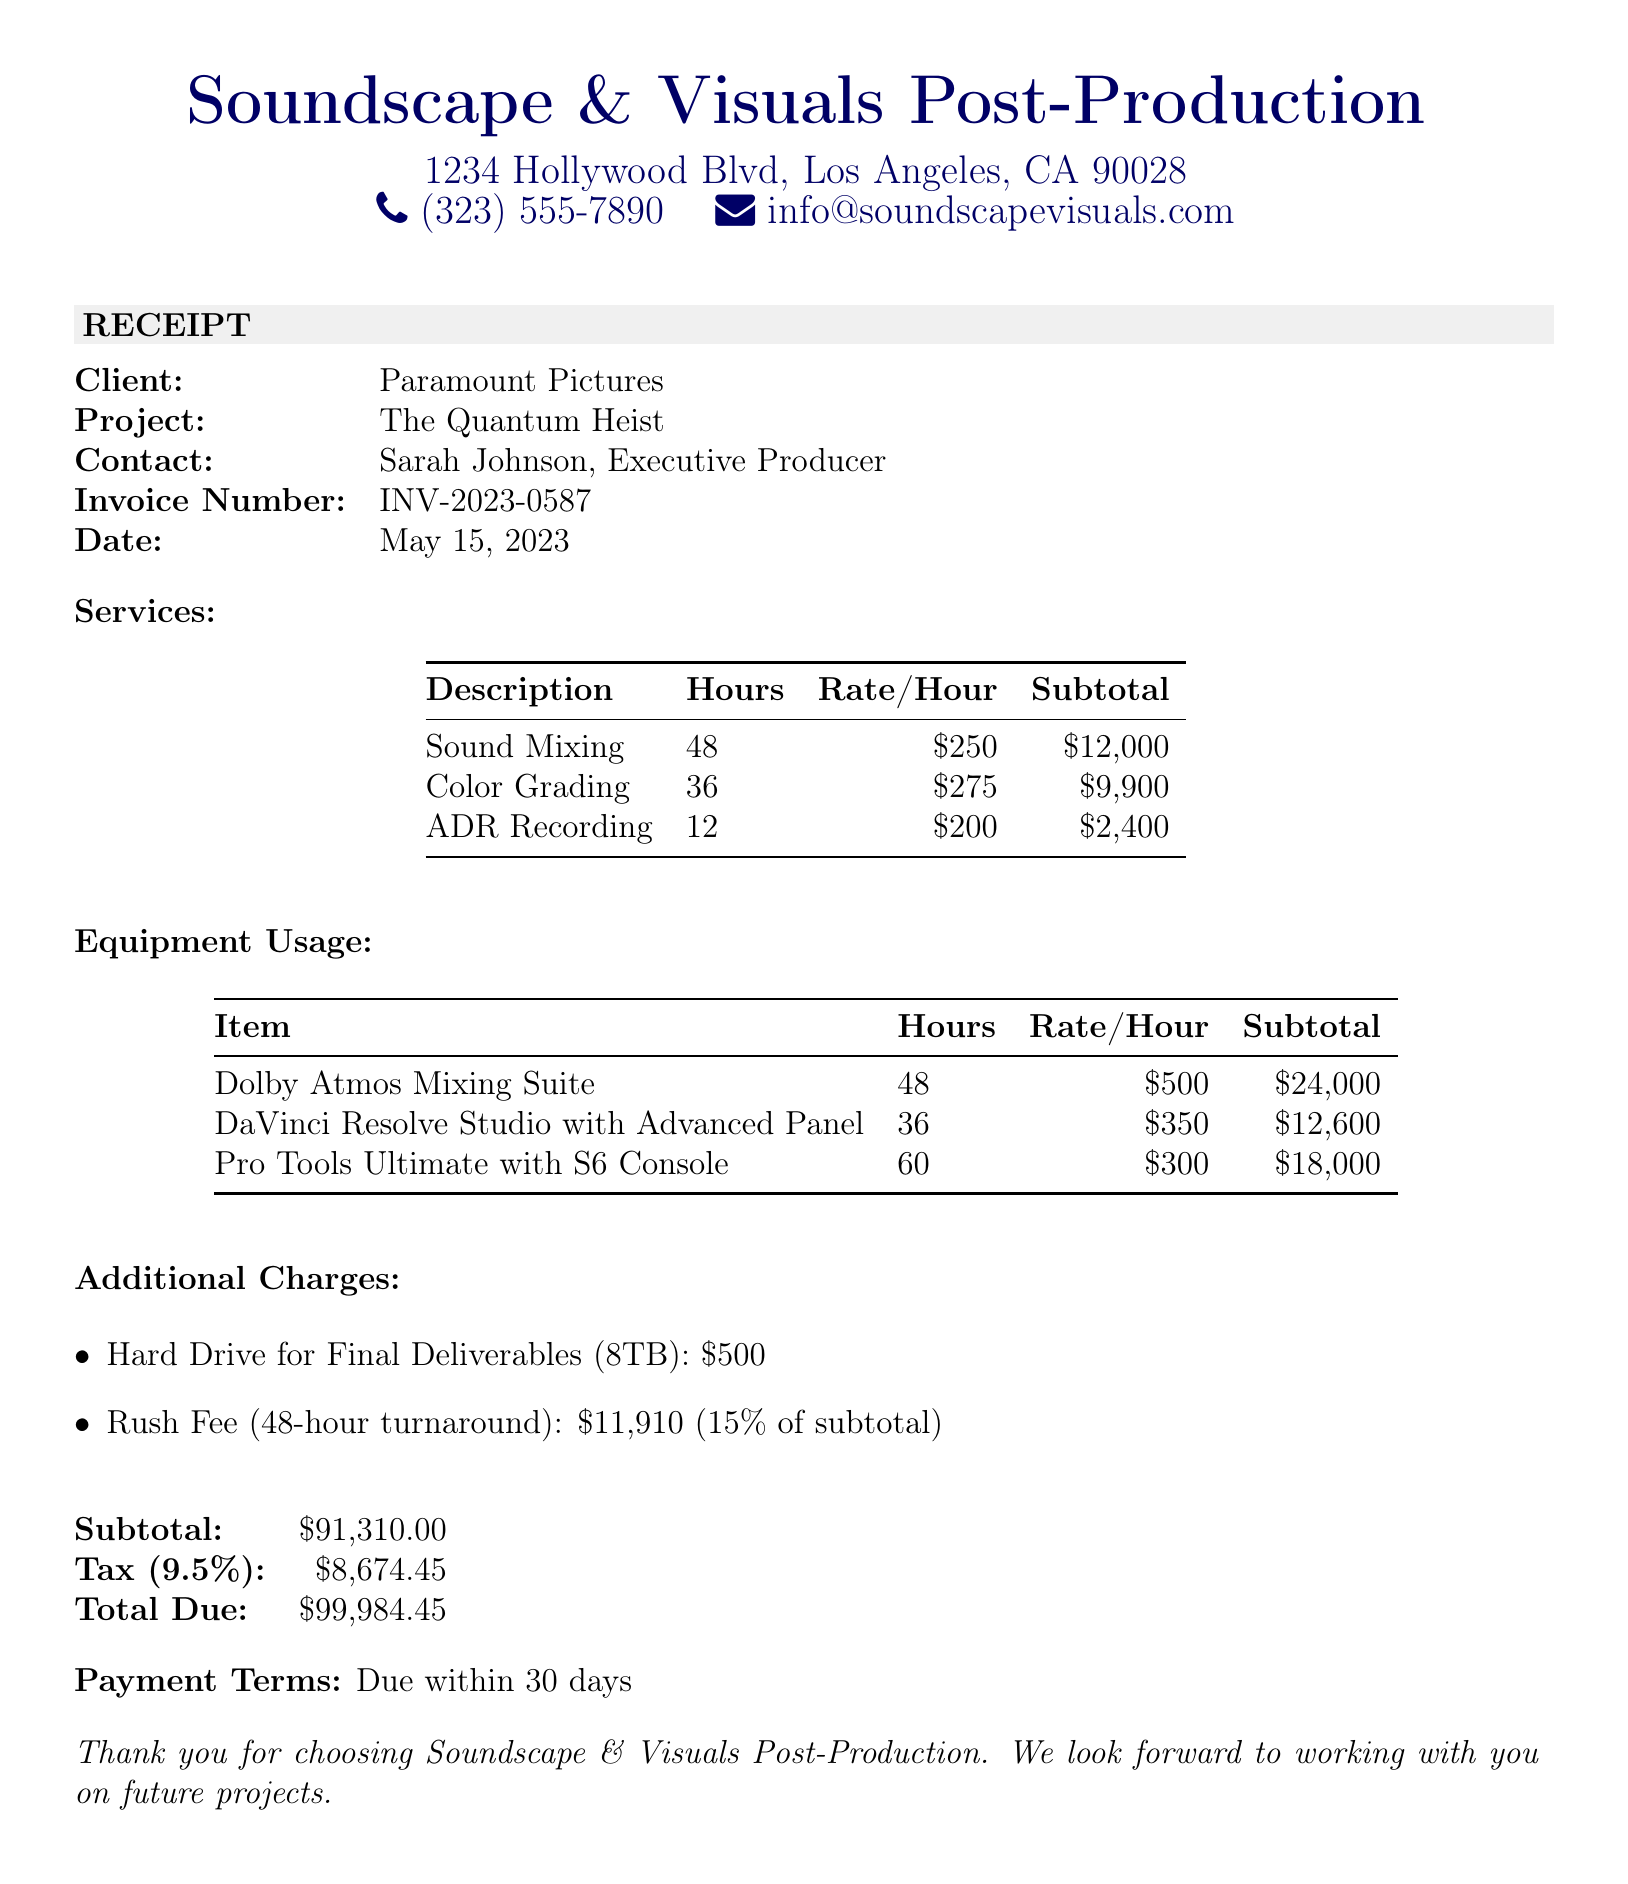What is the studio name? The studio name is listed at the top of the document.
Answer: Soundscape & Visuals Post-Production Who is the contact person for the client? The document specifies the client contact in the client section.
Answer: Sarah Johnson, Executive Producer What is the invoice number? The invoice number can be found in the client information section.
Answer: INV-2023-0587 How many hours were billed for Color Grading? The hours for each service are provided in the services section of the document.
Answer: 36 What is the subtotal for equipment usage? The subtotal for equipment usage can be calculated from the equipment usage table.
Answer: $60,600 What is the percentage of the rush fee? The rush fee percentage is explicitly listed in the additional charges section.
Answer: 15% What is the total amount due? The total amount due is clearly stated at the end of the document.
Answer: $99,984.45 What equipment was used for sound mixing? The equipment used for sound mixing is detailed in the equipment usage section.
Answer: Dolby Atmos Mixing Suite What is the tax rate applied? The tax rate is mentioned in the financial summary section of the receipt.
Answer: 9.5% What does the payment terms indicate? The payment terms are mentioned at the end of the document to inform the client of their obligations.
Answer: Due within 30 days 